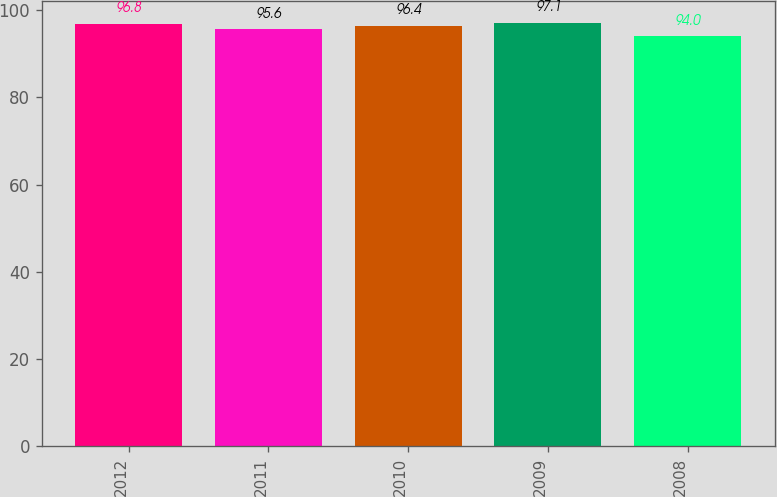<chart> <loc_0><loc_0><loc_500><loc_500><bar_chart><fcel>2012<fcel>2011<fcel>2010<fcel>2009<fcel>2008<nl><fcel>96.8<fcel>95.6<fcel>96.4<fcel>97.1<fcel>94<nl></chart> 